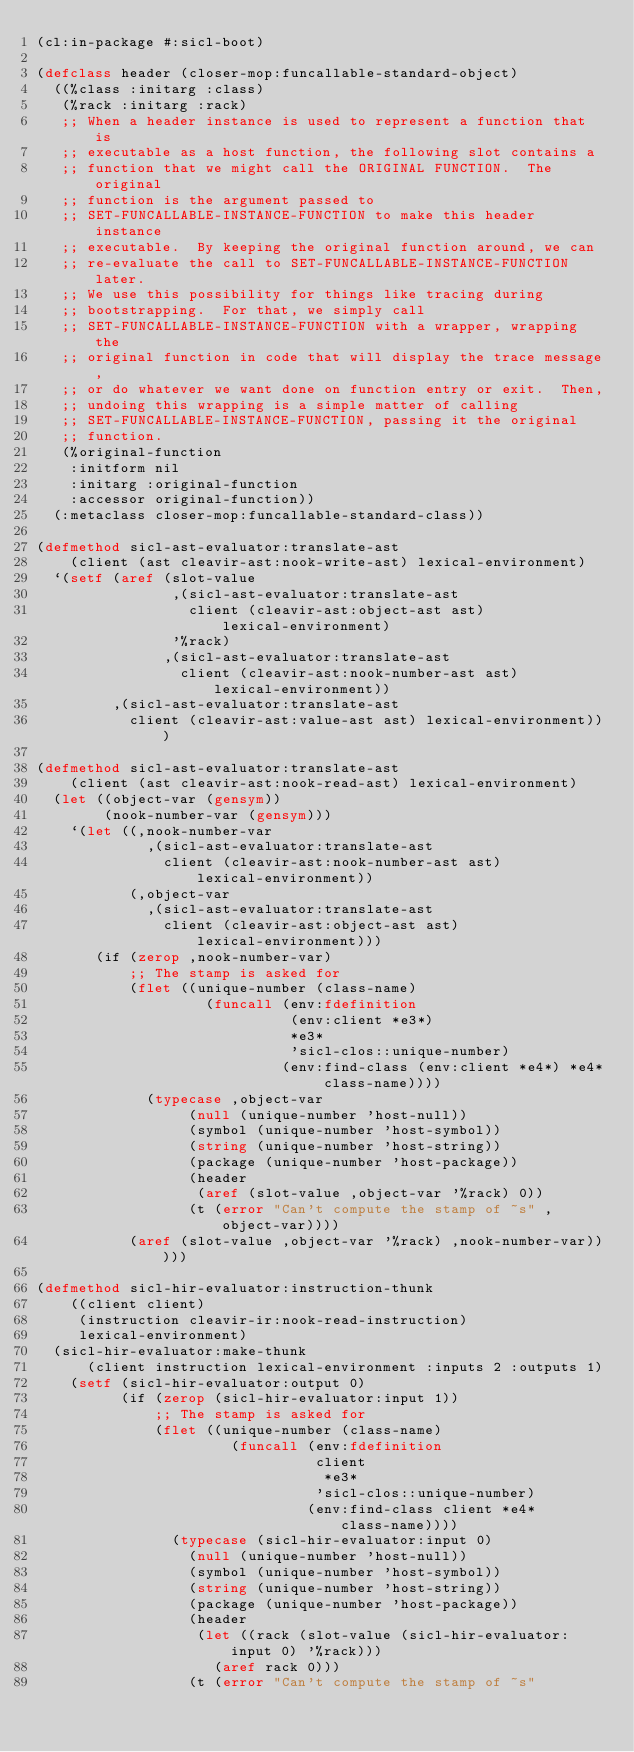Convert code to text. <code><loc_0><loc_0><loc_500><loc_500><_Lisp_>(cl:in-package #:sicl-boot)

(defclass header (closer-mop:funcallable-standard-object)
  ((%class :initarg :class)
   (%rack :initarg :rack)
   ;; When a header instance is used to represent a function that is
   ;; executable as a host function, the following slot contains a
   ;; function that we might call the ORIGINAL FUNCTION.  The original
   ;; function is the argument passed to
   ;; SET-FUNCALLABLE-INSTANCE-FUNCTION to make this header instance
   ;; executable.  By keeping the original function around, we can
   ;; re-evaluate the call to SET-FUNCALLABLE-INSTANCE-FUNCTION later.
   ;; We use this possibility for things like tracing during
   ;; bootstrapping.  For that, we simply call
   ;; SET-FUNCALLABLE-INSTANCE-FUNCTION with a wrapper, wrapping the
   ;; original function in code that will display the trace message,
   ;; or do whatever we want done on function entry or exit.  Then,
   ;; undoing this wrapping is a simple matter of calling
   ;; SET-FUNCALLABLE-INSTANCE-FUNCTION, passing it the original
   ;; function.
   (%original-function
    :initform nil
    :initarg :original-function
    :accessor original-function))
  (:metaclass closer-mop:funcallable-standard-class))

(defmethod sicl-ast-evaluator:translate-ast
    (client (ast cleavir-ast:nook-write-ast) lexical-environment)
  `(setf (aref (slot-value
                ,(sicl-ast-evaluator:translate-ast
                  client (cleavir-ast:object-ast ast) lexical-environment)
                '%rack)
               ,(sicl-ast-evaluator:translate-ast
                 client (cleavir-ast:nook-number-ast ast) lexical-environment))
         ,(sicl-ast-evaluator:translate-ast
           client (cleavir-ast:value-ast ast) lexical-environment)))

(defmethod sicl-ast-evaluator:translate-ast
    (client (ast cleavir-ast:nook-read-ast) lexical-environment)
  (let ((object-var (gensym))
        (nook-number-var (gensym)))
    `(let ((,nook-number-var
             ,(sicl-ast-evaluator:translate-ast
               client (cleavir-ast:nook-number-ast ast) lexical-environment))
           (,object-var
             ,(sicl-ast-evaluator:translate-ast
               client (cleavir-ast:object-ast ast) lexical-environment)))
       (if (zerop ,nook-number-var)
           ;; The stamp is asked for
           (flet ((unique-number (class-name)
                    (funcall (env:fdefinition
                              (env:client *e3*)
                              *e3*
                              'sicl-clos::unique-number)
                             (env:find-class (env:client *e4*) *e4* class-name))))
             (typecase ,object-var
                  (null (unique-number 'host-null))
                  (symbol (unique-number 'host-symbol))
                  (string (unique-number 'host-string))
                  (package (unique-number 'host-package))
                  (header
                   (aref (slot-value ,object-var '%rack) 0))
                  (t (error "Can't compute the stamp of ~s" ,object-var))))
           (aref (slot-value ,object-var '%rack) ,nook-number-var)))))

(defmethod sicl-hir-evaluator:instruction-thunk
    ((client client)
     (instruction cleavir-ir:nook-read-instruction)
     lexical-environment)
  (sicl-hir-evaluator:make-thunk
      (client instruction lexical-environment :inputs 2 :outputs 1)
    (setf (sicl-hir-evaluator:output 0)
          (if (zerop (sicl-hir-evaluator:input 1))
              ;; The stamp is asked for
              (flet ((unique-number (class-name)
                       (funcall (env:fdefinition
                                 client
                                  *e3*
                                 'sicl-clos::unique-number)
                                (env:find-class client *e4* class-name))))
                (typecase (sicl-hir-evaluator:input 0)
                  (null (unique-number 'host-null))
                  (symbol (unique-number 'host-symbol))
                  (string (unique-number 'host-string))
                  (package (unique-number 'host-package))
                  (header
                   (let ((rack (slot-value (sicl-hir-evaluator:input 0) '%rack)))
                     (aref rack 0)))
                  (t (error "Can't compute the stamp of ~s"</code> 